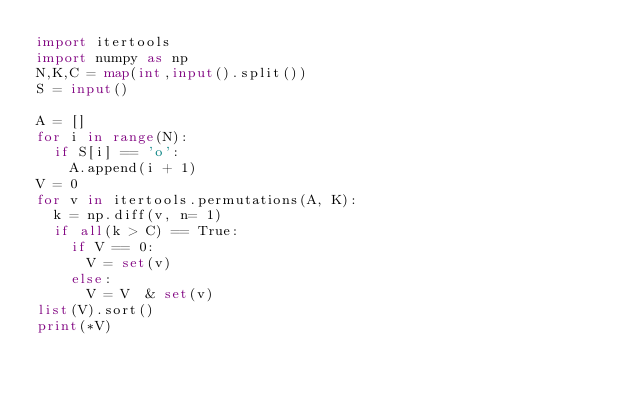<code> <loc_0><loc_0><loc_500><loc_500><_Python_>import itertools
import numpy as np
N,K,C = map(int,input().split())
S = input()

A = []
for i in range(N):
  if S[i] == 'o':
    A.append(i + 1)
V = 0
for v in itertools.permutations(A, K):
  k = np.diff(v, n= 1)
  if all(k > C) == True:
    if V == 0:
      V = set(v)
    else:
      V = V  & set(v)
list(V).sort()
print(*V)</code> 